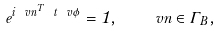Convert formula to latex. <formula><loc_0><loc_0><loc_500><loc_500>e ^ { i \ v n ^ { T } \ t { \ v \phi } } = 1 , \quad v n \in \Gamma _ { B } ,</formula> 